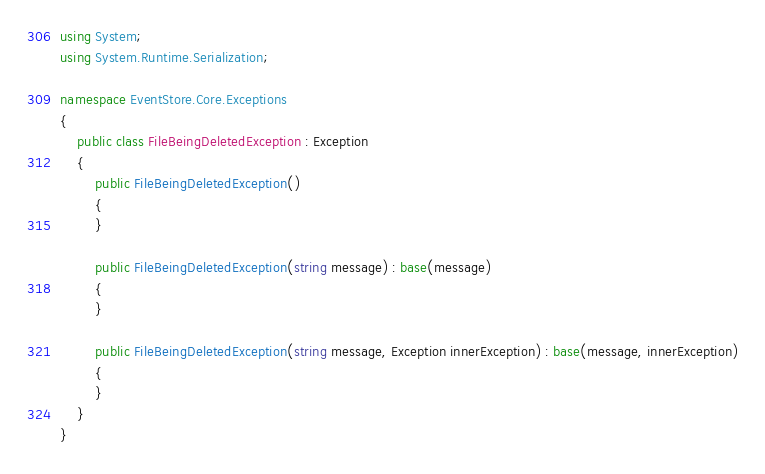<code> <loc_0><loc_0><loc_500><loc_500><_C#_>using System;
using System.Runtime.Serialization;

namespace EventStore.Core.Exceptions
{
    public class FileBeingDeletedException : Exception
    {
        public FileBeingDeletedException()
        {
        }

        public FileBeingDeletedException(string message) : base(message)
        {
        }

        public FileBeingDeletedException(string message, Exception innerException) : base(message, innerException)
        {
        }
    }
}</code> 